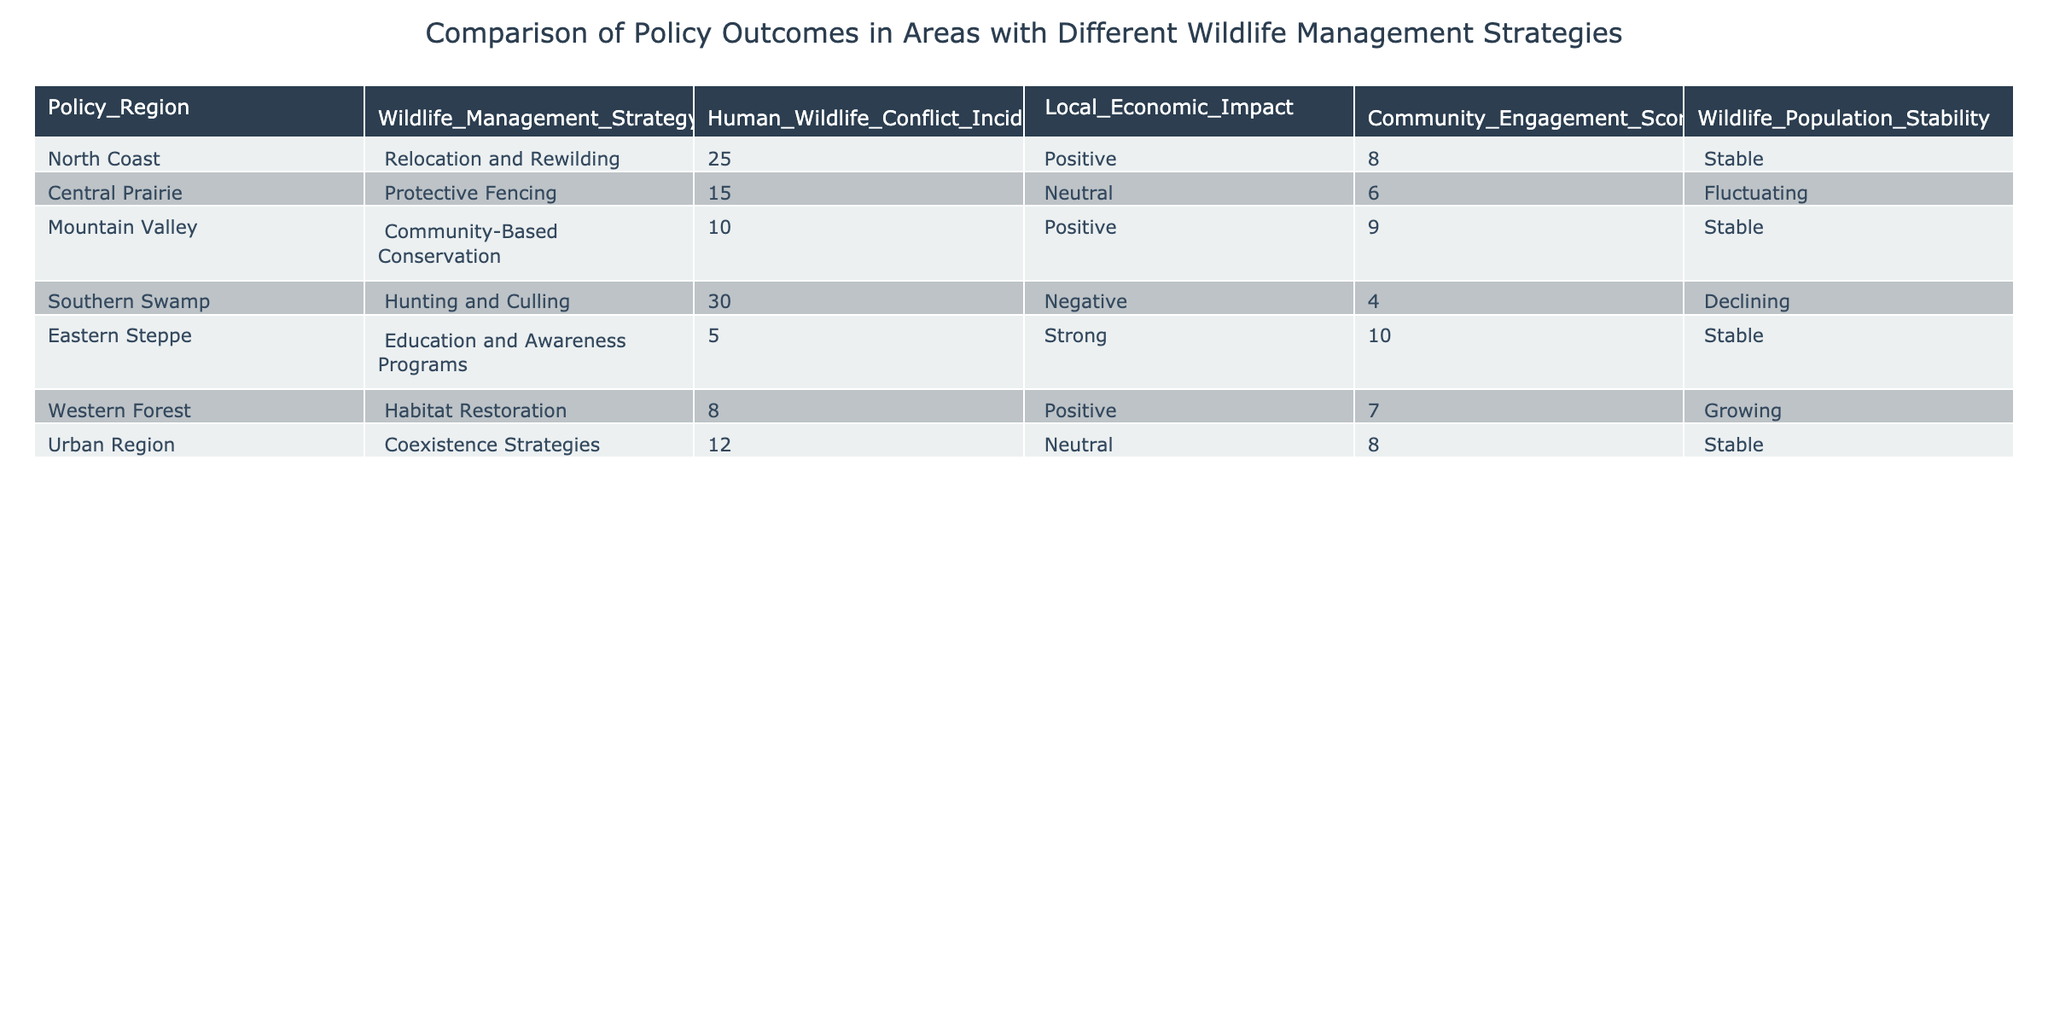What is the Wildlife Management Strategy used in the Eastern Steppe? The table explicitly lists the Wildlife Management Strategy for each region, and for the Eastern Steppe, it is stated as "Education and Awareness Programs."
Answer: Education and Awareness Programs Which region has the highest number of Human Wildlife Conflict Incidents in 2022? By inspecting the Human Wildlife Conflict Incidents column, we see the highest value is 30, observed in the Southern Swamp region.
Answer: Southern Swamp What is the average Community Engagement Score across all regions? To find the average, we add the Community Engagement Scores: (8 + 6 + 9 + 4 + 10 + 7 + 8) = 52. There are 7 regions, so the average is 52/7 ≈ 7.43.
Answer: Approximately 7.43 Is the Wildlife Population Stability in the Mountain Valley region Declining? The table indicates that the Wildlife Population Stability in the Mountain Valley is listed as "Stable," not Declining. Hence, the statement is false.
Answer: No Which region has a Positive Local Economic Impact and what is its Community Engagement Score? The regions with Positive Local Economic Impact are North Coast, Mountain Valley, and Western Forest. Their corresponding Community Engagement Scores are 8, 9, and 7, respectively. Since multiple regions fit the criteria, we will mention all three.
Answer: North Coast (8), Mountain Valley (9), Western Forest (7) What is the difference in Human Wildlife Conflict Incidents between the Southern Swamp and the Eastern Steppe? The Southern Swamp has 30 incidents while the Eastern Steppe has 5. To find the difference, we subtract: 30 - 5 = 25.
Answer: 25 Are the regions with coexisting strategies less prone to Human Wildlife Conflict compared to those involving Hunting and Culling? The Urban Region has 12 incidents with Coexistence Strategies, while the Southern Swamp has 30 incidents involving Hunting and Culling. Thus, the Urban Region is less prone to conflict.
Answer: Yes Which Wildlife Management Strategy shows the best Community Engagement Score? The highest Community Engagement Score in the table is 10, found in the Eastern Steppe under Education and Awareness Programs, which indicates it has the best score.
Answer: Education and Awareness Programs What is the total number of Human Wildlife Conflict Incidents for all regions with Positive Local Economic Impact? The regions with a Positive Local Economic Impact are North Coast (25 incidents), Mountain Valley (10 incidents), and Western Forest (8 incidents). Adding these incidents gives 25 + 10 + 8 = 43.
Answer: 43 